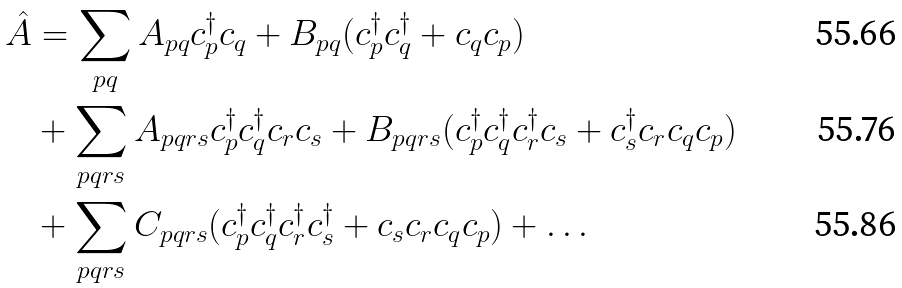Convert formula to latex. <formula><loc_0><loc_0><loc_500><loc_500>\hat { A } & = \sum _ { p q } A _ { p q } c ^ { \dag } _ { p } c _ { q } + B _ { p q } ( c ^ { \dag } _ { p } c ^ { \dag } _ { q } + c _ { q } c _ { p } ) \\ & + \sum _ { p q r s } A _ { p q r s } c ^ { \dag } _ { p } c ^ { \dag } _ { q } c _ { r } c _ { s } + B _ { p q r s } ( c ^ { \dag } _ { p } c ^ { \dag } _ { q } c ^ { \dag } _ { r } c _ { s } + c ^ { \dag } _ { s } c _ { r } c _ { q } c _ { p } ) \\ & + \sum _ { p q r s } C _ { p q r s } ( c ^ { \dag } _ { p } c ^ { \dag } _ { q } c ^ { \dag } _ { r } c ^ { \dag } _ { s } + c _ { s } c _ { r } c _ { q } c _ { p } ) + \dots</formula> 